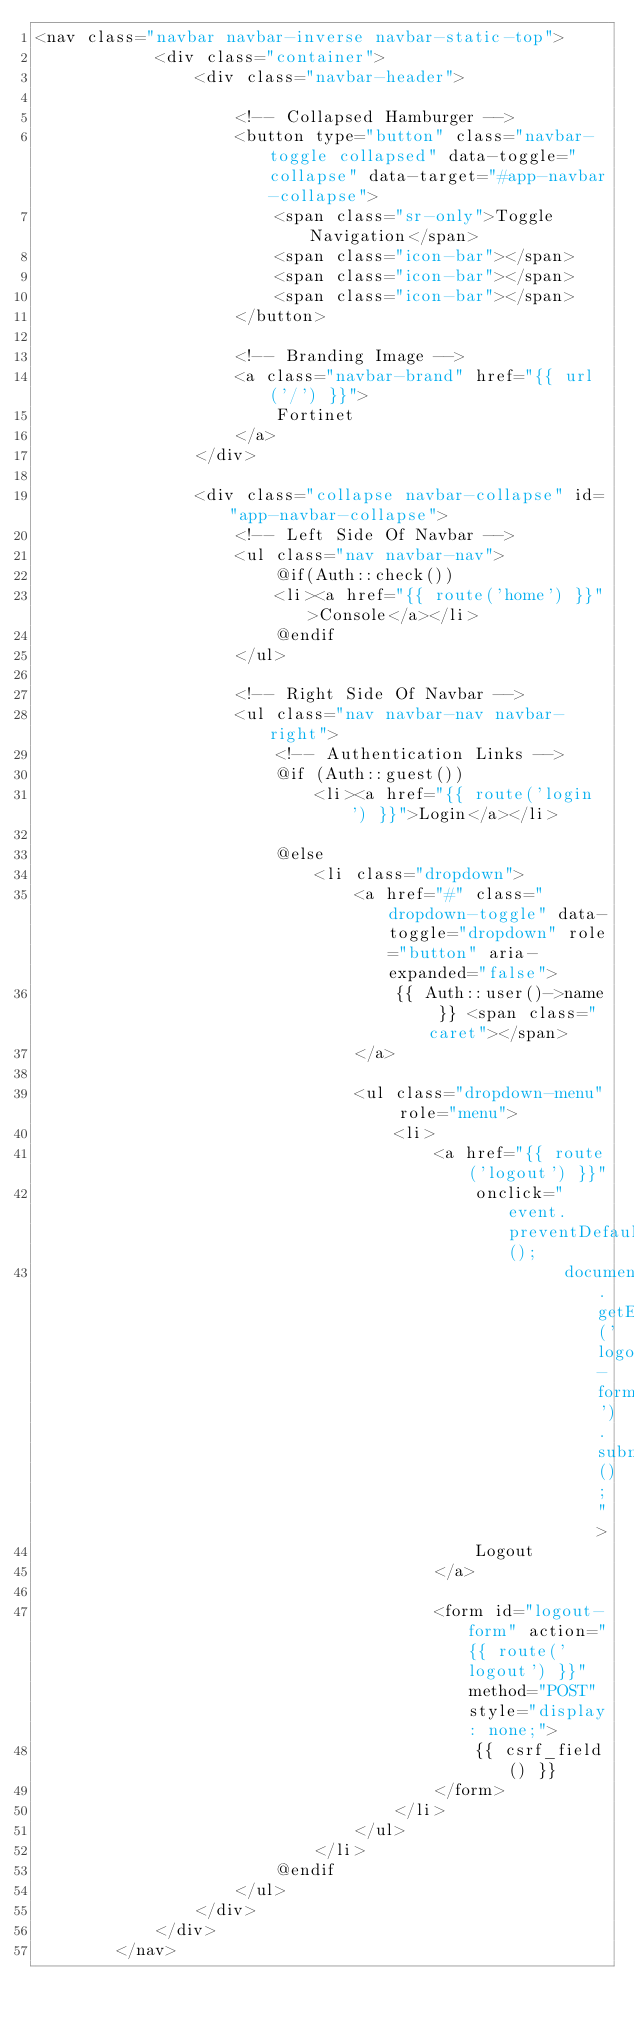<code> <loc_0><loc_0><loc_500><loc_500><_PHP_><nav class="navbar navbar-inverse navbar-static-top">
            <div class="container">
                <div class="navbar-header">

                    <!-- Collapsed Hamburger -->
                    <button type="button" class="navbar-toggle collapsed" data-toggle="collapse" data-target="#app-navbar-collapse">
                        <span class="sr-only">Toggle Navigation</span>
                        <span class="icon-bar"></span>
                        <span class="icon-bar"></span>
                        <span class="icon-bar"></span>
                    </button>

                    <!-- Branding Image -->
                    <a class="navbar-brand" href="{{ url('/') }}">
                        Fortinet
                    </a>
                </div>

                <div class="collapse navbar-collapse" id="app-navbar-collapse">
                    <!-- Left Side Of Navbar -->
                    <ul class="nav navbar-nav">
                        @if(Auth::check())
                        <li><a href="{{ route('home') }}">Console</a></li>
                        @endif
                    </ul>

                    <!-- Right Side Of Navbar -->
                    <ul class="nav navbar-nav navbar-right">
                        <!-- Authentication Links -->
                        @if (Auth::guest())
                            <li><a href="{{ route('login') }}">Login</a></li>
                            
                        @else
                            <li class="dropdown">
                                <a href="#" class="dropdown-toggle" data-toggle="dropdown" role="button" aria-expanded="false">
                                    {{ Auth::user()->name }} <span class="caret"></span>
                                </a>

                                <ul class="dropdown-menu" role="menu">
                                    <li>
                                        <a href="{{ route('logout') }}"
                                            onclick="event.preventDefault();
                                                     document.getElementById('logout-form').submit();">
                                            Logout
                                        </a>

                                        <form id="logout-form" action="{{ route('logout') }}" method="POST" style="display: none;">
                                            {{ csrf_field() }}
                                        </form>
                                    </li>
                                </ul>
                            </li>
                        @endif
                    </ul>
                </div>
            </div> 
        </nav>  </code> 